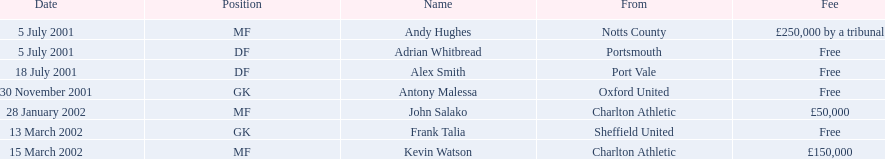Who were all the participants? Andy Hughes, Adrian Whitbread, Alex Smith, Antony Malessa, John Salako, Frank Talia, Kevin Watson. What were the transfer costs for these participants? £250,000 by a tribunal, Free, Free, Free, £50,000, Free, £150,000. Among these, which belong to andy hughes and john salako? £250,000 by a tribunal, £50,000. Which of these is greater? £250,000 by a tribunal. Which participant demanded this cost? Andy Hughes. 